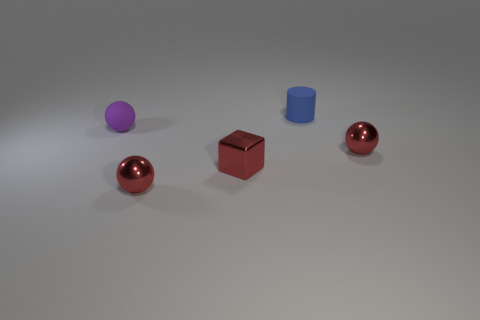Add 2 large green matte cylinders. How many objects exist? 7 Subtract all cylinders. How many objects are left? 4 Subtract all purple rubber things. Subtract all small rubber cylinders. How many objects are left? 3 Add 2 blue matte cylinders. How many blue matte cylinders are left? 3 Add 2 big rubber balls. How many big rubber balls exist? 2 Subtract 1 blue cylinders. How many objects are left? 4 